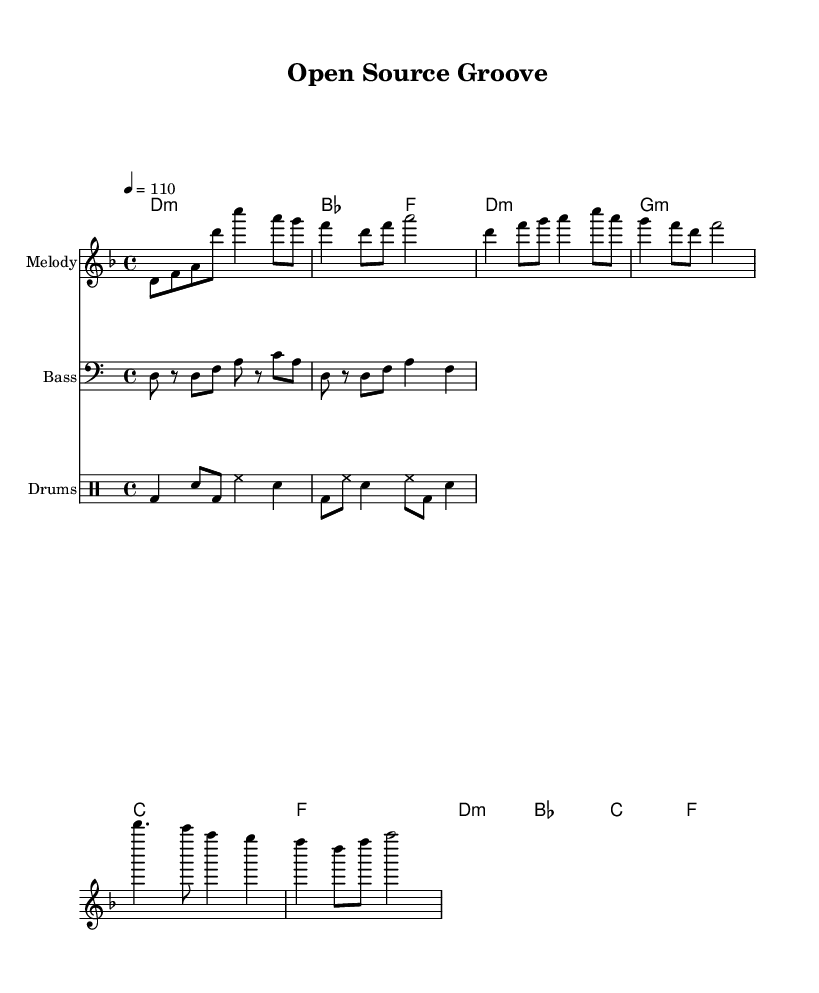what is the key signature of this music? The key signature is indicated by the presence of one flat, which suggests the music is in D minor.
Answer: D minor what is the time signature of this music? The time signature appears at the beginning of the score as 4/4, which indicates that there are four beats in each measure.
Answer: 4/4 what is the tempo marking of this music? The tempo marking is indicated as 4 equals 110, which specifies the speed at which the piece should be played.
Answer: 110 how many measures are there in the chorus section? By counting the measures in the written part of the chorus, we find there are two measures stated in the score.
Answer: 2 which instrument plays the melody? The melody is written in the first staff with the label "Melody," indicating that this staff represents the instrument playing the melody.
Answer: Melody what chord is played during the verse section? The verse section shows a progression that includes D minor, G minor, C major, and F major chords specifically noted in the chord symbols.
Answer: D minor, G minor, C major, F major what theme is represented in the lyrics of this composition? The lyrics celebrate the open-source culture and innovation, as indicated by the phrases "Sharing knowledge" and "contribute with pride" reflecting themes of collaboration and community.
Answer: Open-source culture 